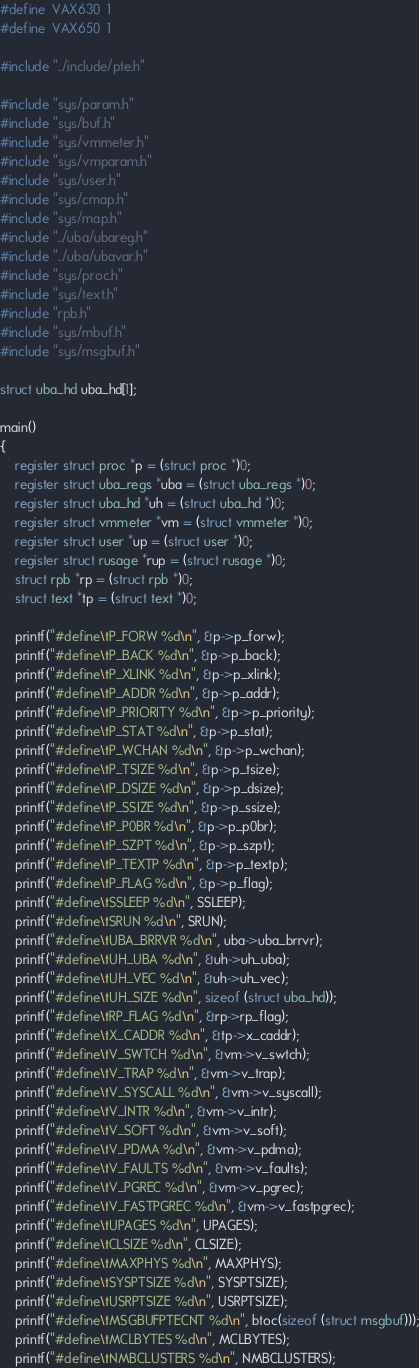Convert code to text. <code><loc_0><loc_0><loc_500><loc_500><_C_>#define	VAX630	1
#define	VAX650	1

#include "../include/pte.h"

#include "sys/param.h"
#include "sys/buf.h"
#include "sys/vmmeter.h"
#include "sys/vmparam.h"
#include "sys/user.h"
#include "sys/cmap.h"
#include "sys/map.h"
#include "../uba/ubareg.h"
#include "../uba/ubavar.h"
#include "sys/proc.h"
#include "sys/text.h"
#include "rpb.h"
#include "sys/mbuf.h"
#include "sys/msgbuf.h"

struct uba_hd uba_hd[1];

main()
{
	register struct proc *p = (struct proc *)0;
	register struct uba_regs *uba = (struct uba_regs *)0;
	register struct uba_hd *uh = (struct uba_hd *)0;
	register struct vmmeter *vm = (struct vmmeter *)0;
	register struct user *up = (struct user *)0;
	register struct rusage *rup = (struct rusage *)0;
	struct rpb *rp = (struct rpb *)0;
	struct text *tp = (struct text *)0;

	printf("#define\tP_FORW %d\n", &p->p_forw);
	printf("#define\tP_BACK %d\n", &p->p_back);
	printf("#define\tP_XLINK %d\n", &p->p_xlink);
	printf("#define\tP_ADDR %d\n", &p->p_addr);
	printf("#define\tP_PRIORITY %d\n", &p->p_priority);
	printf("#define\tP_STAT %d\n", &p->p_stat);
	printf("#define\tP_WCHAN %d\n", &p->p_wchan);
	printf("#define\tP_TSIZE %d\n", &p->p_tsize);
	printf("#define\tP_DSIZE %d\n", &p->p_dsize);
	printf("#define\tP_SSIZE %d\n", &p->p_ssize);
	printf("#define\tP_P0BR %d\n", &p->p_p0br);
	printf("#define\tP_SZPT %d\n", &p->p_szpt);
	printf("#define\tP_TEXTP %d\n", &p->p_textp);
	printf("#define\tP_FLAG %d\n", &p->p_flag);
	printf("#define\tSSLEEP %d\n", SSLEEP);
	printf("#define\tSRUN %d\n", SRUN);
	printf("#define\tUBA_BRRVR %d\n", uba->uba_brrvr);
	printf("#define\tUH_UBA %d\n", &uh->uh_uba);
	printf("#define\tUH_VEC %d\n", &uh->uh_vec);
	printf("#define\tUH_SIZE %d\n", sizeof (struct uba_hd));
	printf("#define\tRP_FLAG %d\n", &rp->rp_flag);
	printf("#define\tX_CADDR %d\n", &tp->x_caddr);
	printf("#define\tV_SWTCH %d\n", &vm->v_swtch);
	printf("#define\tV_TRAP %d\n", &vm->v_trap);
	printf("#define\tV_SYSCALL %d\n", &vm->v_syscall);
	printf("#define\tV_INTR %d\n", &vm->v_intr);
	printf("#define\tV_SOFT %d\n", &vm->v_soft);
	printf("#define\tV_PDMA %d\n", &vm->v_pdma);
	printf("#define\tV_FAULTS %d\n", &vm->v_faults);
	printf("#define\tV_PGREC %d\n", &vm->v_pgrec);
	printf("#define\tV_FASTPGREC %d\n", &vm->v_fastpgrec);
	printf("#define\tUPAGES %d\n", UPAGES);
	printf("#define\tCLSIZE %d\n", CLSIZE);
	printf("#define\tMAXPHYS %d\n", MAXPHYS);
	printf("#define\tSYSPTSIZE %d\n", SYSPTSIZE);
	printf("#define\tUSRPTSIZE %d\n", USRPTSIZE);
	printf("#define\tMSGBUFPTECNT %d\n", btoc(sizeof (struct msgbuf)));
	printf("#define\tMCLBYTES %d\n", MCLBYTES);
	printf("#define\tNMBCLUSTERS %d\n", NMBCLUSTERS);</code> 